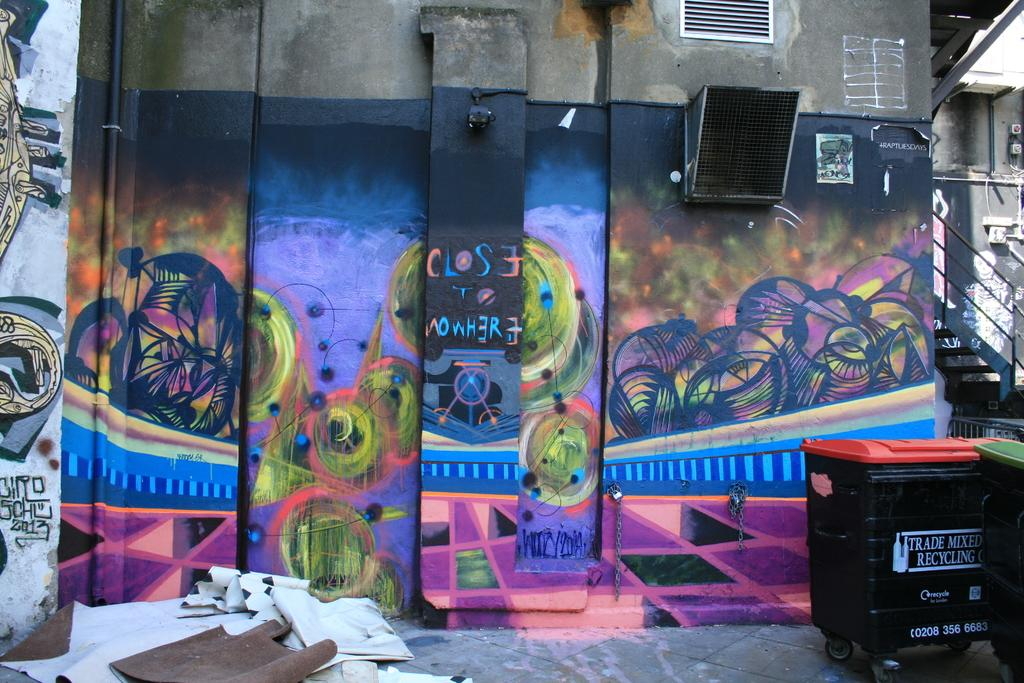<image>
Write a terse but informative summary of the picture. An alley has graffiti painted on the walls and a trash bin that says Trade Mixed Recycling. 